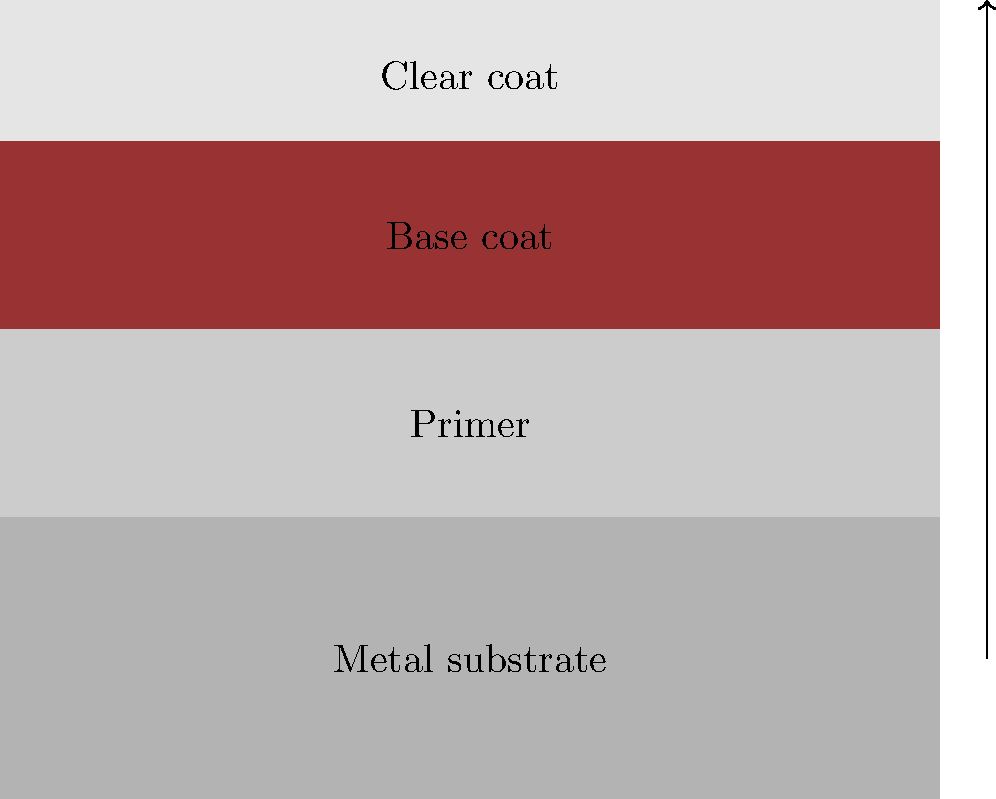In the cross-sectional view of automotive paint layers shown above, which surface treatment (A or B) would likely provide better paint adhesion and why? To determine which surface treatment would provide better paint adhesion, we need to consider the following steps:

1. Understand the purpose of surface treatments:
   Surface treatments are applied to improve paint adhesion and corrosion resistance.

2. Compare the two options:
   A. Untreated: No additional preparation of the metal substrate.
   B. Phosphate coating: A chemical treatment applied to the metal substrate.

3. Analyze the phosphate coating:
   - Creates a microscopically rough surface on the metal.
   - Increases the surface area for paint adhesion.
   - Forms a chemical bond with the primer.

4. Consider the benefits of phosphate coating:
   - Improved mechanical adhesion due to increased surface area.
   - Enhanced chemical bonding between the substrate and primer.
   - Better corrosion resistance under the paint layers.

5. Evaluate the untreated surface:
   - Smooth surface with less area for paint adhesion.
   - No additional chemical bonding properties.
   - More susceptible to corrosion under the paint.

6. Conclude based on adhesion properties:
   The phosphate coating (B) would provide better paint adhesion due to its increased surface area and chemical bonding properties.
Answer: B (Phosphate coating), due to increased surface area and chemical bonding. 